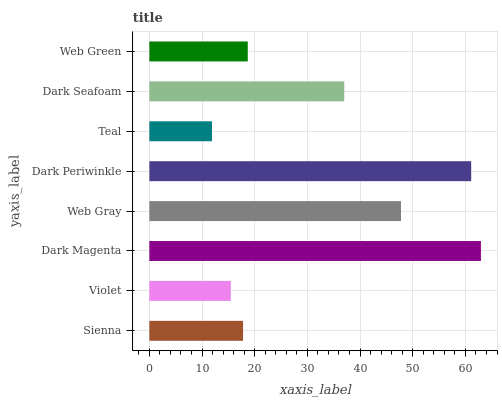Is Teal the minimum?
Answer yes or no. Yes. Is Dark Magenta the maximum?
Answer yes or no. Yes. Is Violet the minimum?
Answer yes or no. No. Is Violet the maximum?
Answer yes or no. No. Is Sienna greater than Violet?
Answer yes or no. Yes. Is Violet less than Sienna?
Answer yes or no. Yes. Is Violet greater than Sienna?
Answer yes or no. No. Is Sienna less than Violet?
Answer yes or no. No. Is Dark Seafoam the high median?
Answer yes or no. Yes. Is Web Green the low median?
Answer yes or no. Yes. Is Web Gray the high median?
Answer yes or no. No. Is Sienna the low median?
Answer yes or no. No. 